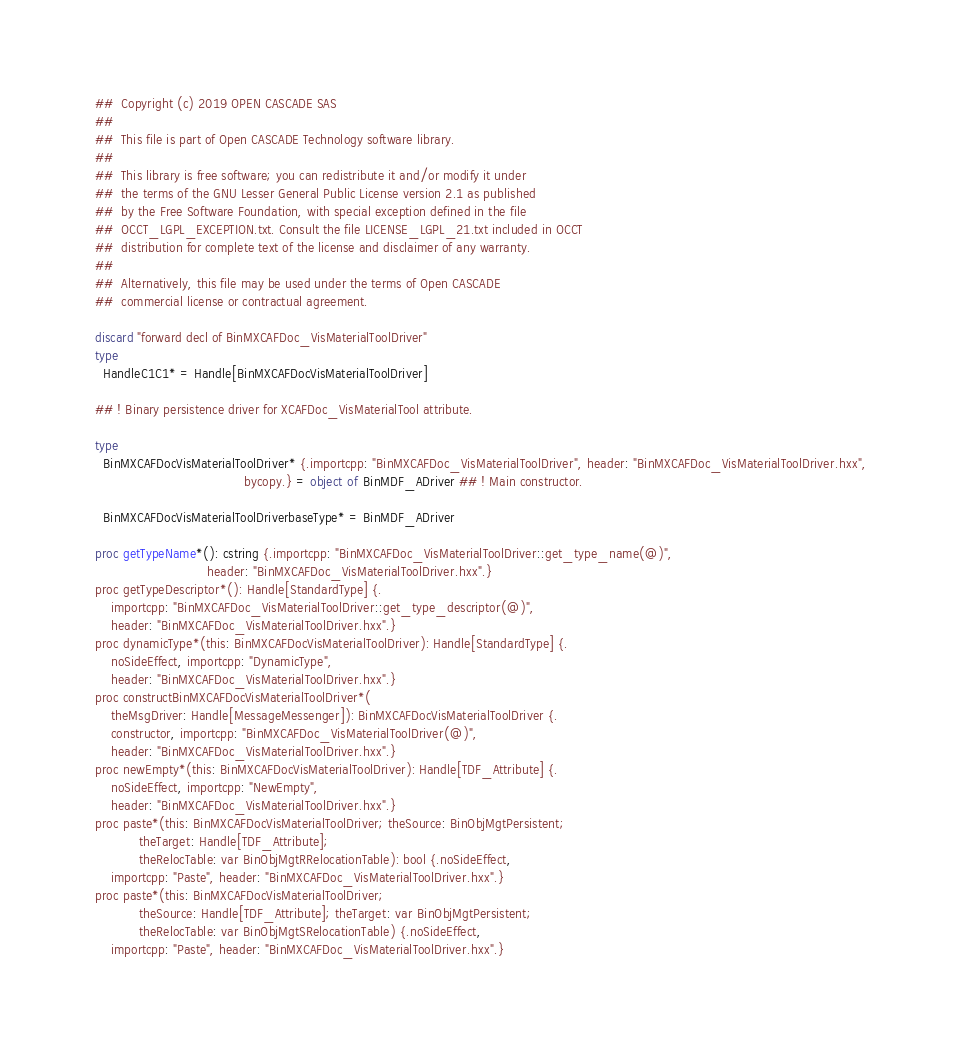<code> <loc_0><loc_0><loc_500><loc_500><_Nim_>##  Copyright (c) 2019 OPEN CASCADE SAS
##
##  This file is part of Open CASCADE Technology software library.
##
##  This library is free software; you can redistribute it and/or modify it under
##  the terms of the GNU Lesser General Public License version 2.1 as published
##  by the Free Software Foundation, with special exception defined in the file
##  OCCT_LGPL_EXCEPTION.txt. Consult the file LICENSE_LGPL_21.txt included in OCCT
##  distribution for complete text of the license and disclaimer of any warranty.
##
##  Alternatively, this file may be used under the terms of Open CASCADE
##  commercial license or contractual agreement.

discard "forward decl of BinMXCAFDoc_VisMaterialToolDriver"
type
  HandleC1C1* = Handle[BinMXCAFDocVisMaterialToolDriver]

## ! Binary persistence driver for XCAFDoc_VisMaterialTool attribute.

type
  BinMXCAFDocVisMaterialToolDriver* {.importcpp: "BinMXCAFDoc_VisMaterialToolDriver", header: "BinMXCAFDoc_VisMaterialToolDriver.hxx",
                                     bycopy.} = object of BinMDF_ADriver ## ! Main constructor.

  BinMXCAFDocVisMaterialToolDriverbaseType* = BinMDF_ADriver

proc getTypeName*(): cstring {.importcpp: "BinMXCAFDoc_VisMaterialToolDriver::get_type_name(@)",
                            header: "BinMXCAFDoc_VisMaterialToolDriver.hxx".}
proc getTypeDescriptor*(): Handle[StandardType] {.
    importcpp: "BinMXCAFDoc_VisMaterialToolDriver::get_type_descriptor(@)",
    header: "BinMXCAFDoc_VisMaterialToolDriver.hxx".}
proc dynamicType*(this: BinMXCAFDocVisMaterialToolDriver): Handle[StandardType] {.
    noSideEffect, importcpp: "DynamicType",
    header: "BinMXCAFDoc_VisMaterialToolDriver.hxx".}
proc constructBinMXCAFDocVisMaterialToolDriver*(
    theMsgDriver: Handle[MessageMessenger]): BinMXCAFDocVisMaterialToolDriver {.
    constructor, importcpp: "BinMXCAFDoc_VisMaterialToolDriver(@)",
    header: "BinMXCAFDoc_VisMaterialToolDriver.hxx".}
proc newEmpty*(this: BinMXCAFDocVisMaterialToolDriver): Handle[TDF_Attribute] {.
    noSideEffect, importcpp: "NewEmpty",
    header: "BinMXCAFDoc_VisMaterialToolDriver.hxx".}
proc paste*(this: BinMXCAFDocVisMaterialToolDriver; theSource: BinObjMgtPersistent;
           theTarget: Handle[TDF_Attribute];
           theRelocTable: var BinObjMgtRRelocationTable): bool {.noSideEffect,
    importcpp: "Paste", header: "BinMXCAFDoc_VisMaterialToolDriver.hxx".}
proc paste*(this: BinMXCAFDocVisMaterialToolDriver;
           theSource: Handle[TDF_Attribute]; theTarget: var BinObjMgtPersistent;
           theRelocTable: var BinObjMgtSRelocationTable) {.noSideEffect,
    importcpp: "Paste", header: "BinMXCAFDoc_VisMaterialToolDriver.hxx".}

























</code> 